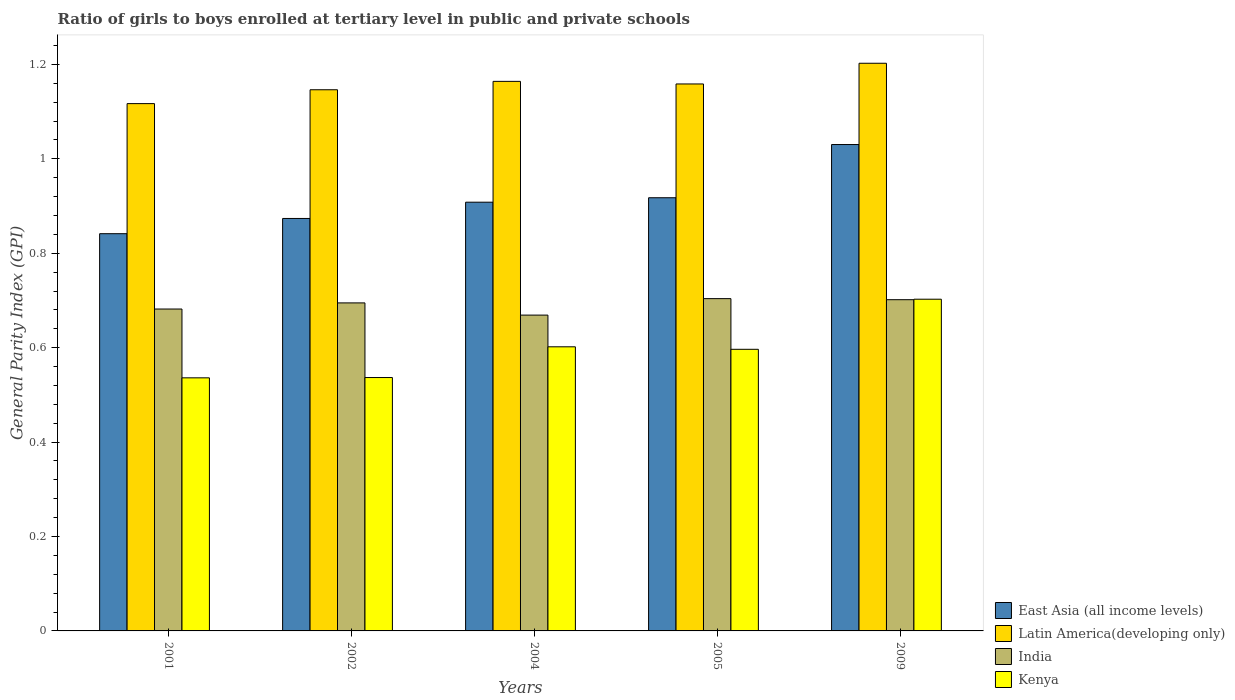How many different coloured bars are there?
Make the answer very short. 4. Are the number of bars per tick equal to the number of legend labels?
Provide a short and direct response. Yes. Are the number of bars on each tick of the X-axis equal?
Give a very brief answer. Yes. How many bars are there on the 5th tick from the right?
Offer a very short reply. 4. What is the general parity index in Latin America(developing only) in 2002?
Your answer should be compact. 1.15. Across all years, what is the maximum general parity index in Kenya?
Provide a short and direct response. 0.7. Across all years, what is the minimum general parity index in India?
Provide a succinct answer. 0.67. What is the total general parity index in East Asia (all income levels) in the graph?
Provide a succinct answer. 4.57. What is the difference between the general parity index in Latin America(developing only) in 2005 and that in 2009?
Provide a succinct answer. -0.04. What is the difference between the general parity index in Latin America(developing only) in 2002 and the general parity index in Kenya in 2004?
Your response must be concise. 0.54. What is the average general parity index in India per year?
Offer a terse response. 0.69. In the year 2002, what is the difference between the general parity index in India and general parity index in East Asia (all income levels)?
Ensure brevity in your answer.  -0.18. What is the ratio of the general parity index in Kenya in 2001 to that in 2005?
Ensure brevity in your answer.  0.9. Is the difference between the general parity index in India in 2002 and 2009 greater than the difference between the general parity index in East Asia (all income levels) in 2002 and 2009?
Provide a succinct answer. Yes. What is the difference between the highest and the second highest general parity index in Kenya?
Offer a terse response. 0.1. What is the difference between the highest and the lowest general parity index in Kenya?
Provide a short and direct response. 0.17. Is the sum of the general parity index in Kenya in 2005 and 2009 greater than the maximum general parity index in Latin America(developing only) across all years?
Your response must be concise. Yes. What does the 4th bar from the left in 2004 represents?
Offer a terse response. Kenya. What does the 4th bar from the right in 2005 represents?
Your answer should be compact. East Asia (all income levels). Is it the case that in every year, the sum of the general parity index in Latin America(developing only) and general parity index in Kenya is greater than the general parity index in East Asia (all income levels)?
Your answer should be very brief. Yes. Are all the bars in the graph horizontal?
Offer a terse response. No. Are the values on the major ticks of Y-axis written in scientific E-notation?
Your response must be concise. No. Does the graph contain any zero values?
Make the answer very short. No. Does the graph contain grids?
Give a very brief answer. No. Where does the legend appear in the graph?
Offer a terse response. Bottom right. How are the legend labels stacked?
Provide a short and direct response. Vertical. What is the title of the graph?
Your answer should be compact. Ratio of girls to boys enrolled at tertiary level in public and private schools. Does "Korea (Republic)" appear as one of the legend labels in the graph?
Keep it short and to the point. No. What is the label or title of the Y-axis?
Ensure brevity in your answer.  General Parity Index (GPI). What is the General Parity Index (GPI) in East Asia (all income levels) in 2001?
Provide a succinct answer. 0.84. What is the General Parity Index (GPI) of Latin America(developing only) in 2001?
Provide a short and direct response. 1.12. What is the General Parity Index (GPI) of India in 2001?
Ensure brevity in your answer.  0.68. What is the General Parity Index (GPI) of Kenya in 2001?
Offer a terse response. 0.54. What is the General Parity Index (GPI) in East Asia (all income levels) in 2002?
Your response must be concise. 0.87. What is the General Parity Index (GPI) of Latin America(developing only) in 2002?
Your response must be concise. 1.15. What is the General Parity Index (GPI) in India in 2002?
Keep it short and to the point. 0.69. What is the General Parity Index (GPI) in Kenya in 2002?
Your response must be concise. 0.54. What is the General Parity Index (GPI) in East Asia (all income levels) in 2004?
Provide a succinct answer. 0.91. What is the General Parity Index (GPI) of Latin America(developing only) in 2004?
Ensure brevity in your answer.  1.16. What is the General Parity Index (GPI) in India in 2004?
Give a very brief answer. 0.67. What is the General Parity Index (GPI) of Kenya in 2004?
Ensure brevity in your answer.  0.6. What is the General Parity Index (GPI) in East Asia (all income levels) in 2005?
Offer a terse response. 0.92. What is the General Parity Index (GPI) in Latin America(developing only) in 2005?
Your answer should be very brief. 1.16. What is the General Parity Index (GPI) in India in 2005?
Make the answer very short. 0.7. What is the General Parity Index (GPI) of Kenya in 2005?
Provide a succinct answer. 0.6. What is the General Parity Index (GPI) in East Asia (all income levels) in 2009?
Ensure brevity in your answer.  1.03. What is the General Parity Index (GPI) of Latin America(developing only) in 2009?
Offer a very short reply. 1.2. What is the General Parity Index (GPI) in India in 2009?
Make the answer very short. 0.7. What is the General Parity Index (GPI) in Kenya in 2009?
Make the answer very short. 0.7. Across all years, what is the maximum General Parity Index (GPI) of East Asia (all income levels)?
Provide a succinct answer. 1.03. Across all years, what is the maximum General Parity Index (GPI) in Latin America(developing only)?
Offer a terse response. 1.2. Across all years, what is the maximum General Parity Index (GPI) in India?
Your answer should be compact. 0.7. Across all years, what is the maximum General Parity Index (GPI) in Kenya?
Make the answer very short. 0.7. Across all years, what is the minimum General Parity Index (GPI) of East Asia (all income levels)?
Provide a succinct answer. 0.84. Across all years, what is the minimum General Parity Index (GPI) of Latin America(developing only)?
Offer a terse response. 1.12. Across all years, what is the minimum General Parity Index (GPI) of India?
Your response must be concise. 0.67. Across all years, what is the minimum General Parity Index (GPI) of Kenya?
Make the answer very short. 0.54. What is the total General Parity Index (GPI) of East Asia (all income levels) in the graph?
Your response must be concise. 4.57. What is the total General Parity Index (GPI) in Latin America(developing only) in the graph?
Provide a succinct answer. 5.79. What is the total General Parity Index (GPI) in India in the graph?
Provide a short and direct response. 3.45. What is the total General Parity Index (GPI) in Kenya in the graph?
Keep it short and to the point. 2.97. What is the difference between the General Parity Index (GPI) in East Asia (all income levels) in 2001 and that in 2002?
Give a very brief answer. -0.03. What is the difference between the General Parity Index (GPI) of Latin America(developing only) in 2001 and that in 2002?
Your answer should be very brief. -0.03. What is the difference between the General Parity Index (GPI) of India in 2001 and that in 2002?
Offer a terse response. -0.01. What is the difference between the General Parity Index (GPI) of Kenya in 2001 and that in 2002?
Your response must be concise. -0. What is the difference between the General Parity Index (GPI) in East Asia (all income levels) in 2001 and that in 2004?
Your answer should be compact. -0.07. What is the difference between the General Parity Index (GPI) in Latin America(developing only) in 2001 and that in 2004?
Provide a short and direct response. -0.05. What is the difference between the General Parity Index (GPI) in India in 2001 and that in 2004?
Your response must be concise. 0.01. What is the difference between the General Parity Index (GPI) of Kenya in 2001 and that in 2004?
Give a very brief answer. -0.07. What is the difference between the General Parity Index (GPI) in East Asia (all income levels) in 2001 and that in 2005?
Offer a terse response. -0.08. What is the difference between the General Parity Index (GPI) of Latin America(developing only) in 2001 and that in 2005?
Give a very brief answer. -0.04. What is the difference between the General Parity Index (GPI) of India in 2001 and that in 2005?
Provide a succinct answer. -0.02. What is the difference between the General Parity Index (GPI) of Kenya in 2001 and that in 2005?
Offer a terse response. -0.06. What is the difference between the General Parity Index (GPI) in East Asia (all income levels) in 2001 and that in 2009?
Your answer should be compact. -0.19. What is the difference between the General Parity Index (GPI) in Latin America(developing only) in 2001 and that in 2009?
Keep it short and to the point. -0.09. What is the difference between the General Parity Index (GPI) of India in 2001 and that in 2009?
Give a very brief answer. -0.02. What is the difference between the General Parity Index (GPI) of Kenya in 2001 and that in 2009?
Give a very brief answer. -0.17. What is the difference between the General Parity Index (GPI) of East Asia (all income levels) in 2002 and that in 2004?
Ensure brevity in your answer.  -0.03. What is the difference between the General Parity Index (GPI) in Latin America(developing only) in 2002 and that in 2004?
Keep it short and to the point. -0.02. What is the difference between the General Parity Index (GPI) in India in 2002 and that in 2004?
Keep it short and to the point. 0.03. What is the difference between the General Parity Index (GPI) of Kenya in 2002 and that in 2004?
Keep it short and to the point. -0.07. What is the difference between the General Parity Index (GPI) in East Asia (all income levels) in 2002 and that in 2005?
Your answer should be very brief. -0.04. What is the difference between the General Parity Index (GPI) in Latin America(developing only) in 2002 and that in 2005?
Offer a very short reply. -0.01. What is the difference between the General Parity Index (GPI) of India in 2002 and that in 2005?
Your answer should be very brief. -0.01. What is the difference between the General Parity Index (GPI) of Kenya in 2002 and that in 2005?
Your response must be concise. -0.06. What is the difference between the General Parity Index (GPI) of East Asia (all income levels) in 2002 and that in 2009?
Offer a very short reply. -0.16. What is the difference between the General Parity Index (GPI) in Latin America(developing only) in 2002 and that in 2009?
Offer a terse response. -0.06. What is the difference between the General Parity Index (GPI) of India in 2002 and that in 2009?
Keep it short and to the point. -0.01. What is the difference between the General Parity Index (GPI) in Kenya in 2002 and that in 2009?
Your response must be concise. -0.17. What is the difference between the General Parity Index (GPI) in East Asia (all income levels) in 2004 and that in 2005?
Offer a very short reply. -0.01. What is the difference between the General Parity Index (GPI) of Latin America(developing only) in 2004 and that in 2005?
Make the answer very short. 0.01. What is the difference between the General Parity Index (GPI) of India in 2004 and that in 2005?
Keep it short and to the point. -0.03. What is the difference between the General Parity Index (GPI) in Kenya in 2004 and that in 2005?
Your response must be concise. 0.01. What is the difference between the General Parity Index (GPI) in East Asia (all income levels) in 2004 and that in 2009?
Ensure brevity in your answer.  -0.12. What is the difference between the General Parity Index (GPI) in Latin America(developing only) in 2004 and that in 2009?
Provide a short and direct response. -0.04. What is the difference between the General Parity Index (GPI) of India in 2004 and that in 2009?
Ensure brevity in your answer.  -0.03. What is the difference between the General Parity Index (GPI) of Kenya in 2004 and that in 2009?
Your answer should be compact. -0.1. What is the difference between the General Parity Index (GPI) of East Asia (all income levels) in 2005 and that in 2009?
Your answer should be very brief. -0.11. What is the difference between the General Parity Index (GPI) of Latin America(developing only) in 2005 and that in 2009?
Your response must be concise. -0.04. What is the difference between the General Parity Index (GPI) of India in 2005 and that in 2009?
Your answer should be very brief. 0. What is the difference between the General Parity Index (GPI) of Kenya in 2005 and that in 2009?
Make the answer very short. -0.11. What is the difference between the General Parity Index (GPI) in East Asia (all income levels) in 2001 and the General Parity Index (GPI) in Latin America(developing only) in 2002?
Offer a very short reply. -0.3. What is the difference between the General Parity Index (GPI) of East Asia (all income levels) in 2001 and the General Parity Index (GPI) of India in 2002?
Make the answer very short. 0.15. What is the difference between the General Parity Index (GPI) of East Asia (all income levels) in 2001 and the General Parity Index (GPI) of Kenya in 2002?
Offer a very short reply. 0.3. What is the difference between the General Parity Index (GPI) of Latin America(developing only) in 2001 and the General Parity Index (GPI) of India in 2002?
Your response must be concise. 0.42. What is the difference between the General Parity Index (GPI) in Latin America(developing only) in 2001 and the General Parity Index (GPI) in Kenya in 2002?
Your answer should be very brief. 0.58. What is the difference between the General Parity Index (GPI) of India in 2001 and the General Parity Index (GPI) of Kenya in 2002?
Offer a terse response. 0.15. What is the difference between the General Parity Index (GPI) in East Asia (all income levels) in 2001 and the General Parity Index (GPI) in Latin America(developing only) in 2004?
Keep it short and to the point. -0.32. What is the difference between the General Parity Index (GPI) in East Asia (all income levels) in 2001 and the General Parity Index (GPI) in India in 2004?
Ensure brevity in your answer.  0.17. What is the difference between the General Parity Index (GPI) of East Asia (all income levels) in 2001 and the General Parity Index (GPI) of Kenya in 2004?
Provide a short and direct response. 0.24. What is the difference between the General Parity Index (GPI) of Latin America(developing only) in 2001 and the General Parity Index (GPI) of India in 2004?
Offer a very short reply. 0.45. What is the difference between the General Parity Index (GPI) in Latin America(developing only) in 2001 and the General Parity Index (GPI) in Kenya in 2004?
Your answer should be very brief. 0.52. What is the difference between the General Parity Index (GPI) of India in 2001 and the General Parity Index (GPI) of Kenya in 2004?
Keep it short and to the point. 0.08. What is the difference between the General Parity Index (GPI) of East Asia (all income levels) in 2001 and the General Parity Index (GPI) of Latin America(developing only) in 2005?
Your answer should be very brief. -0.32. What is the difference between the General Parity Index (GPI) in East Asia (all income levels) in 2001 and the General Parity Index (GPI) in India in 2005?
Ensure brevity in your answer.  0.14. What is the difference between the General Parity Index (GPI) in East Asia (all income levels) in 2001 and the General Parity Index (GPI) in Kenya in 2005?
Make the answer very short. 0.24. What is the difference between the General Parity Index (GPI) in Latin America(developing only) in 2001 and the General Parity Index (GPI) in India in 2005?
Your answer should be compact. 0.41. What is the difference between the General Parity Index (GPI) in Latin America(developing only) in 2001 and the General Parity Index (GPI) in Kenya in 2005?
Your answer should be compact. 0.52. What is the difference between the General Parity Index (GPI) of India in 2001 and the General Parity Index (GPI) of Kenya in 2005?
Provide a succinct answer. 0.09. What is the difference between the General Parity Index (GPI) of East Asia (all income levels) in 2001 and the General Parity Index (GPI) of Latin America(developing only) in 2009?
Give a very brief answer. -0.36. What is the difference between the General Parity Index (GPI) in East Asia (all income levels) in 2001 and the General Parity Index (GPI) in India in 2009?
Your answer should be very brief. 0.14. What is the difference between the General Parity Index (GPI) in East Asia (all income levels) in 2001 and the General Parity Index (GPI) in Kenya in 2009?
Provide a short and direct response. 0.14. What is the difference between the General Parity Index (GPI) of Latin America(developing only) in 2001 and the General Parity Index (GPI) of India in 2009?
Give a very brief answer. 0.42. What is the difference between the General Parity Index (GPI) of Latin America(developing only) in 2001 and the General Parity Index (GPI) of Kenya in 2009?
Your response must be concise. 0.41. What is the difference between the General Parity Index (GPI) of India in 2001 and the General Parity Index (GPI) of Kenya in 2009?
Provide a succinct answer. -0.02. What is the difference between the General Parity Index (GPI) of East Asia (all income levels) in 2002 and the General Parity Index (GPI) of Latin America(developing only) in 2004?
Offer a very short reply. -0.29. What is the difference between the General Parity Index (GPI) of East Asia (all income levels) in 2002 and the General Parity Index (GPI) of India in 2004?
Your answer should be very brief. 0.2. What is the difference between the General Parity Index (GPI) in East Asia (all income levels) in 2002 and the General Parity Index (GPI) in Kenya in 2004?
Your answer should be very brief. 0.27. What is the difference between the General Parity Index (GPI) of Latin America(developing only) in 2002 and the General Parity Index (GPI) of India in 2004?
Keep it short and to the point. 0.48. What is the difference between the General Parity Index (GPI) in Latin America(developing only) in 2002 and the General Parity Index (GPI) in Kenya in 2004?
Ensure brevity in your answer.  0.54. What is the difference between the General Parity Index (GPI) in India in 2002 and the General Parity Index (GPI) in Kenya in 2004?
Offer a terse response. 0.09. What is the difference between the General Parity Index (GPI) in East Asia (all income levels) in 2002 and the General Parity Index (GPI) in Latin America(developing only) in 2005?
Your answer should be compact. -0.28. What is the difference between the General Parity Index (GPI) in East Asia (all income levels) in 2002 and the General Parity Index (GPI) in India in 2005?
Offer a very short reply. 0.17. What is the difference between the General Parity Index (GPI) of East Asia (all income levels) in 2002 and the General Parity Index (GPI) of Kenya in 2005?
Keep it short and to the point. 0.28. What is the difference between the General Parity Index (GPI) in Latin America(developing only) in 2002 and the General Parity Index (GPI) in India in 2005?
Give a very brief answer. 0.44. What is the difference between the General Parity Index (GPI) of Latin America(developing only) in 2002 and the General Parity Index (GPI) of Kenya in 2005?
Keep it short and to the point. 0.55. What is the difference between the General Parity Index (GPI) in India in 2002 and the General Parity Index (GPI) in Kenya in 2005?
Give a very brief answer. 0.1. What is the difference between the General Parity Index (GPI) in East Asia (all income levels) in 2002 and the General Parity Index (GPI) in Latin America(developing only) in 2009?
Ensure brevity in your answer.  -0.33. What is the difference between the General Parity Index (GPI) of East Asia (all income levels) in 2002 and the General Parity Index (GPI) of India in 2009?
Keep it short and to the point. 0.17. What is the difference between the General Parity Index (GPI) in East Asia (all income levels) in 2002 and the General Parity Index (GPI) in Kenya in 2009?
Provide a short and direct response. 0.17. What is the difference between the General Parity Index (GPI) in Latin America(developing only) in 2002 and the General Parity Index (GPI) in India in 2009?
Your answer should be very brief. 0.44. What is the difference between the General Parity Index (GPI) in Latin America(developing only) in 2002 and the General Parity Index (GPI) in Kenya in 2009?
Your answer should be very brief. 0.44. What is the difference between the General Parity Index (GPI) in India in 2002 and the General Parity Index (GPI) in Kenya in 2009?
Offer a terse response. -0.01. What is the difference between the General Parity Index (GPI) in East Asia (all income levels) in 2004 and the General Parity Index (GPI) in Latin America(developing only) in 2005?
Your response must be concise. -0.25. What is the difference between the General Parity Index (GPI) in East Asia (all income levels) in 2004 and the General Parity Index (GPI) in India in 2005?
Give a very brief answer. 0.2. What is the difference between the General Parity Index (GPI) in East Asia (all income levels) in 2004 and the General Parity Index (GPI) in Kenya in 2005?
Your answer should be compact. 0.31. What is the difference between the General Parity Index (GPI) in Latin America(developing only) in 2004 and the General Parity Index (GPI) in India in 2005?
Make the answer very short. 0.46. What is the difference between the General Parity Index (GPI) of Latin America(developing only) in 2004 and the General Parity Index (GPI) of Kenya in 2005?
Your answer should be very brief. 0.57. What is the difference between the General Parity Index (GPI) in India in 2004 and the General Parity Index (GPI) in Kenya in 2005?
Your response must be concise. 0.07. What is the difference between the General Parity Index (GPI) in East Asia (all income levels) in 2004 and the General Parity Index (GPI) in Latin America(developing only) in 2009?
Offer a very short reply. -0.29. What is the difference between the General Parity Index (GPI) in East Asia (all income levels) in 2004 and the General Parity Index (GPI) in India in 2009?
Provide a succinct answer. 0.21. What is the difference between the General Parity Index (GPI) in East Asia (all income levels) in 2004 and the General Parity Index (GPI) in Kenya in 2009?
Your answer should be compact. 0.21. What is the difference between the General Parity Index (GPI) in Latin America(developing only) in 2004 and the General Parity Index (GPI) in India in 2009?
Ensure brevity in your answer.  0.46. What is the difference between the General Parity Index (GPI) of Latin America(developing only) in 2004 and the General Parity Index (GPI) of Kenya in 2009?
Your response must be concise. 0.46. What is the difference between the General Parity Index (GPI) in India in 2004 and the General Parity Index (GPI) in Kenya in 2009?
Make the answer very short. -0.03. What is the difference between the General Parity Index (GPI) of East Asia (all income levels) in 2005 and the General Parity Index (GPI) of Latin America(developing only) in 2009?
Give a very brief answer. -0.28. What is the difference between the General Parity Index (GPI) of East Asia (all income levels) in 2005 and the General Parity Index (GPI) of India in 2009?
Make the answer very short. 0.22. What is the difference between the General Parity Index (GPI) in East Asia (all income levels) in 2005 and the General Parity Index (GPI) in Kenya in 2009?
Offer a very short reply. 0.21. What is the difference between the General Parity Index (GPI) in Latin America(developing only) in 2005 and the General Parity Index (GPI) in India in 2009?
Your answer should be very brief. 0.46. What is the difference between the General Parity Index (GPI) in Latin America(developing only) in 2005 and the General Parity Index (GPI) in Kenya in 2009?
Your response must be concise. 0.46. What is the difference between the General Parity Index (GPI) of India in 2005 and the General Parity Index (GPI) of Kenya in 2009?
Offer a terse response. 0. What is the average General Parity Index (GPI) in East Asia (all income levels) per year?
Your answer should be compact. 0.91. What is the average General Parity Index (GPI) in Latin America(developing only) per year?
Offer a terse response. 1.16. What is the average General Parity Index (GPI) of India per year?
Your answer should be very brief. 0.69. What is the average General Parity Index (GPI) of Kenya per year?
Your response must be concise. 0.59. In the year 2001, what is the difference between the General Parity Index (GPI) in East Asia (all income levels) and General Parity Index (GPI) in Latin America(developing only)?
Ensure brevity in your answer.  -0.28. In the year 2001, what is the difference between the General Parity Index (GPI) in East Asia (all income levels) and General Parity Index (GPI) in India?
Your response must be concise. 0.16. In the year 2001, what is the difference between the General Parity Index (GPI) in East Asia (all income levels) and General Parity Index (GPI) in Kenya?
Your answer should be very brief. 0.31. In the year 2001, what is the difference between the General Parity Index (GPI) of Latin America(developing only) and General Parity Index (GPI) of India?
Ensure brevity in your answer.  0.44. In the year 2001, what is the difference between the General Parity Index (GPI) of Latin America(developing only) and General Parity Index (GPI) of Kenya?
Provide a short and direct response. 0.58. In the year 2001, what is the difference between the General Parity Index (GPI) of India and General Parity Index (GPI) of Kenya?
Give a very brief answer. 0.15. In the year 2002, what is the difference between the General Parity Index (GPI) in East Asia (all income levels) and General Parity Index (GPI) in Latin America(developing only)?
Offer a terse response. -0.27. In the year 2002, what is the difference between the General Parity Index (GPI) in East Asia (all income levels) and General Parity Index (GPI) in India?
Give a very brief answer. 0.18. In the year 2002, what is the difference between the General Parity Index (GPI) of East Asia (all income levels) and General Parity Index (GPI) of Kenya?
Give a very brief answer. 0.34. In the year 2002, what is the difference between the General Parity Index (GPI) of Latin America(developing only) and General Parity Index (GPI) of India?
Your response must be concise. 0.45. In the year 2002, what is the difference between the General Parity Index (GPI) in Latin America(developing only) and General Parity Index (GPI) in Kenya?
Offer a very short reply. 0.61. In the year 2002, what is the difference between the General Parity Index (GPI) of India and General Parity Index (GPI) of Kenya?
Your answer should be very brief. 0.16. In the year 2004, what is the difference between the General Parity Index (GPI) in East Asia (all income levels) and General Parity Index (GPI) in Latin America(developing only)?
Keep it short and to the point. -0.26. In the year 2004, what is the difference between the General Parity Index (GPI) of East Asia (all income levels) and General Parity Index (GPI) of India?
Give a very brief answer. 0.24. In the year 2004, what is the difference between the General Parity Index (GPI) of East Asia (all income levels) and General Parity Index (GPI) of Kenya?
Ensure brevity in your answer.  0.31. In the year 2004, what is the difference between the General Parity Index (GPI) of Latin America(developing only) and General Parity Index (GPI) of India?
Your answer should be compact. 0.5. In the year 2004, what is the difference between the General Parity Index (GPI) of Latin America(developing only) and General Parity Index (GPI) of Kenya?
Offer a terse response. 0.56. In the year 2004, what is the difference between the General Parity Index (GPI) of India and General Parity Index (GPI) of Kenya?
Provide a succinct answer. 0.07. In the year 2005, what is the difference between the General Parity Index (GPI) in East Asia (all income levels) and General Parity Index (GPI) in Latin America(developing only)?
Offer a very short reply. -0.24. In the year 2005, what is the difference between the General Parity Index (GPI) in East Asia (all income levels) and General Parity Index (GPI) in India?
Ensure brevity in your answer.  0.21. In the year 2005, what is the difference between the General Parity Index (GPI) of East Asia (all income levels) and General Parity Index (GPI) of Kenya?
Your answer should be very brief. 0.32. In the year 2005, what is the difference between the General Parity Index (GPI) of Latin America(developing only) and General Parity Index (GPI) of India?
Provide a succinct answer. 0.45. In the year 2005, what is the difference between the General Parity Index (GPI) of Latin America(developing only) and General Parity Index (GPI) of Kenya?
Keep it short and to the point. 0.56. In the year 2005, what is the difference between the General Parity Index (GPI) in India and General Parity Index (GPI) in Kenya?
Keep it short and to the point. 0.11. In the year 2009, what is the difference between the General Parity Index (GPI) in East Asia (all income levels) and General Parity Index (GPI) in Latin America(developing only)?
Make the answer very short. -0.17. In the year 2009, what is the difference between the General Parity Index (GPI) of East Asia (all income levels) and General Parity Index (GPI) of India?
Ensure brevity in your answer.  0.33. In the year 2009, what is the difference between the General Parity Index (GPI) in East Asia (all income levels) and General Parity Index (GPI) in Kenya?
Give a very brief answer. 0.33. In the year 2009, what is the difference between the General Parity Index (GPI) in Latin America(developing only) and General Parity Index (GPI) in India?
Keep it short and to the point. 0.5. In the year 2009, what is the difference between the General Parity Index (GPI) of Latin America(developing only) and General Parity Index (GPI) of Kenya?
Provide a succinct answer. 0.5. In the year 2009, what is the difference between the General Parity Index (GPI) in India and General Parity Index (GPI) in Kenya?
Provide a short and direct response. -0. What is the ratio of the General Parity Index (GPI) of East Asia (all income levels) in 2001 to that in 2002?
Provide a short and direct response. 0.96. What is the ratio of the General Parity Index (GPI) of Latin America(developing only) in 2001 to that in 2002?
Offer a terse response. 0.97. What is the ratio of the General Parity Index (GPI) of India in 2001 to that in 2002?
Offer a very short reply. 0.98. What is the ratio of the General Parity Index (GPI) in East Asia (all income levels) in 2001 to that in 2004?
Your answer should be very brief. 0.93. What is the ratio of the General Parity Index (GPI) in Latin America(developing only) in 2001 to that in 2004?
Your response must be concise. 0.96. What is the ratio of the General Parity Index (GPI) of India in 2001 to that in 2004?
Ensure brevity in your answer.  1.02. What is the ratio of the General Parity Index (GPI) in Kenya in 2001 to that in 2004?
Your answer should be compact. 0.89. What is the ratio of the General Parity Index (GPI) in East Asia (all income levels) in 2001 to that in 2005?
Provide a short and direct response. 0.92. What is the ratio of the General Parity Index (GPI) in Latin America(developing only) in 2001 to that in 2005?
Provide a short and direct response. 0.96. What is the ratio of the General Parity Index (GPI) in India in 2001 to that in 2005?
Give a very brief answer. 0.97. What is the ratio of the General Parity Index (GPI) of Kenya in 2001 to that in 2005?
Ensure brevity in your answer.  0.9. What is the ratio of the General Parity Index (GPI) of East Asia (all income levels) in 2001 to that in 2009?
Your answer should be very brief. 0.82. What is the ratio of the General Parity Index (GPI) in Latin America(developing only) in 2001 to that in 2009?
Give a very brief answer. 0.93. What is the ratio of the General Parity Index (GPI) of India in 2001 to that in 2009?
Ensure brevity in your answer.  0.97. What is the ratio of the General Parity Index (GPI) in Kenya in 2001 to that in 2009?
Your response must be concise. 0.76. What is the ratio of the General Parity Index (GPI) in East Asia (all income levels) in 2002 to that in 2004?
Provide a short and direct response. 0.96. What is the ratio of the General Parity Index (GPI) of Latin America(developing only) in 2002 to that in 2004?
Give a very brief answer. 0.98. What is the ratio of the General Parity Index (GPI) in India in 2002 to that in 2004?
Your answer should be very brief. 1.04. What is the ratio of the General Parity Index (GPI) in Kenya in 2002 to that in 2004?
Offer a terse response. 0.89. What is the ratio of the General Parity Index (GPI) of East Asia (all income levels) in 2002 to that in 2005?
Offer a very short reply. 0.95. What is the ratio of the General Parity Index (GPI) of India in 2002 to that in 2005?
Provide a succinct answer. 0.99. What is the ratio of the General Parity Index (GPI) of Kenya in 2002 to that in 2005?
Your response must be concise. 0.9. What is the ratio of the General Parity Index (GPI) of East Asia (all income levels) in 2002 to that in 2009?
Provide a succinct answer. 0.85. What is the ratio of the General Parity Index (GPI) of Latin America(developing only) in 2002 to that in 2009?
Keep it short and to the point. 0.95. What is the ratio of the General Parity Index (GPI) of India in 2002 to that in 2009?
Your answer should be very brief. 0.99. What is the ratio of the General Parity Index (GPI) in Kenya in 2002 to that in 2009?
Offer a terse response. 0.76. What is the ratio of the General Parity Index (GPI) in India in 2004 to that in 2005?
Provide a succinct answer. 0.95. What is the ratio of the General Parity Index (GPI) of Kenya in 2004 to that in 2005?
Your response must be concise. 1.01. What is the ratio of the General Parity Index (GPI) of East Asia (all income levels) in 2004 to that in 2009?
Offer a very short reply. 0.88. What is the ratio of the General Parity Index (GPI) of Latin America(developing only) in 2004 to that in 2009?
Keep it short and to the point. 0.97. What is the ratio of the General Parity Index (GPI) of India in 2004 to that in 2009?
Your answer should be compact. 0.95. What is the ratio of the General Parity Index (GPI) in Kenya in 2004 to that in 2009?
Offer a very short reply. 0.86. What is the ratio of the General Parity Index (GPI) of East Asia (all income levels) in 2005 to that in 2009?
Give a very brief answer. 0.89. What is the ratio of the General Parity Index (GPI) of Latin America(developing only) in 2005 to that in 2009?
Your answer should be very brief. 0.96. What is the ratio of the General Parity Index (GPI) of India in 2005 to that in 2009?
Ensure brevity in your answer.  1. What is the ratio of the General Parity Index (GPI) in Kenya in 2005 to that in 2009?
Provide a short and direct response. 0.85. What is the difference between the highest and the second highest General Parity Index (GPI) in East Asia (all income levels)?
Your response must be concise. 0.11. What is the difference between the highest and the second highest General Parity Index (GPI) in Latin America(developing only)?
Make the answer very short. 0.04. What is the difference between the highest and the second highest General Parity Index (GPI) in India?
Offer a terse response. 0. What is the difference between the highest and the second highest General Parity Index (GPI) in Kenya?
Your answer should be very brief. 0.1. What is the difference between the highest and the lowest General Parity Index (GPI) in East Asia (all income levels)?
Your answer should be compact. 0.19. What is the difference between the highest and the lowest General Parity Index (GPI) in Latin America(developing only)?
Your response must be concise. 0.09. What is the difference between the highest and the lowest General Parity Index (GPI) in India?
Provide a succinct answer. 0.03. What is the difference between the highest and the lowest General Parity Index (GPI) of Kenya?
Your answer should be compact. 0.17. 